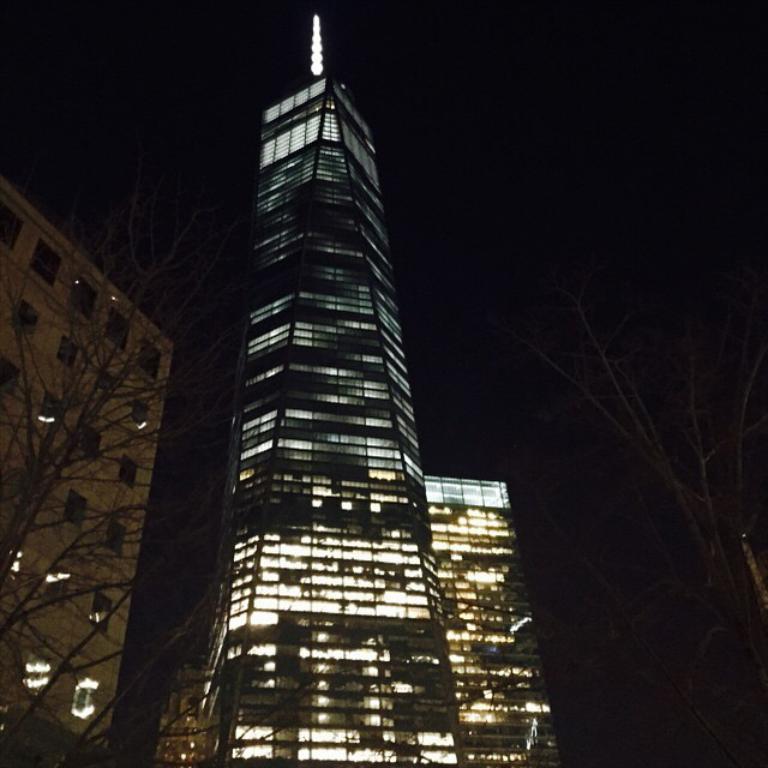Describe this image in one or two sentences. In this image I can see there are trees on either side of this image, in the middle there are buildings with lights, at the top there is the sky. 